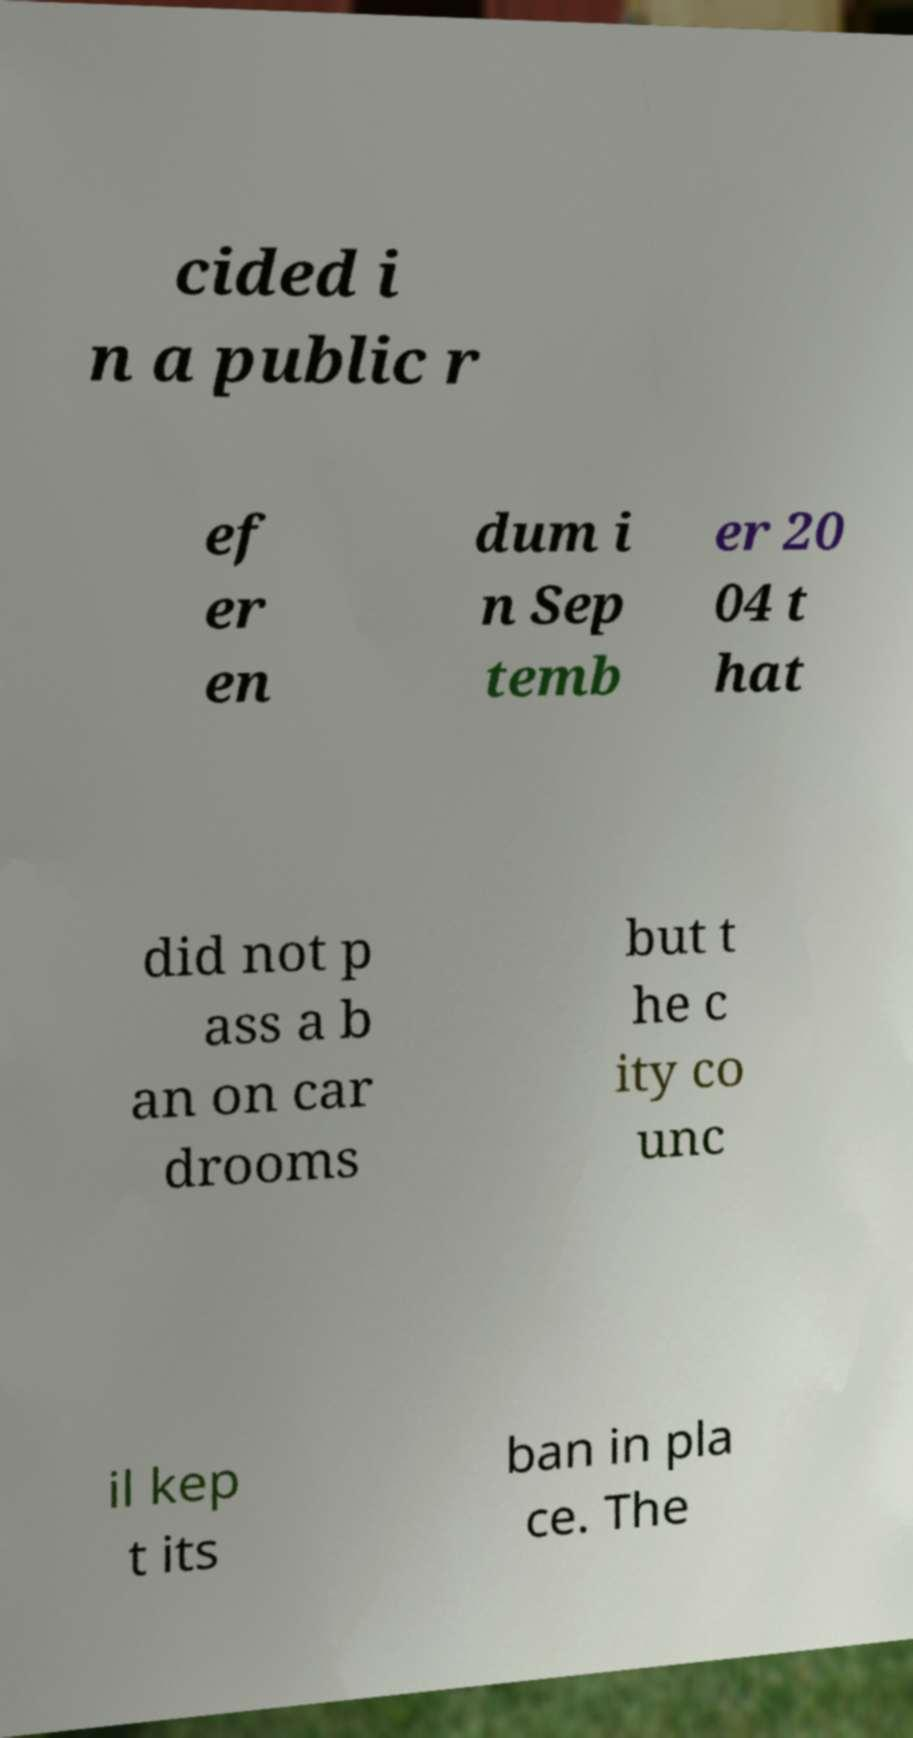What messages or text are displayed in this image? I need them in a readable, typed format. cided i n a public r ef er en dum i n Sep temb er 20 04 t hat did not p ass a b an on car drooms but t he c ity co unc il kep t its ban in pla ce. The 